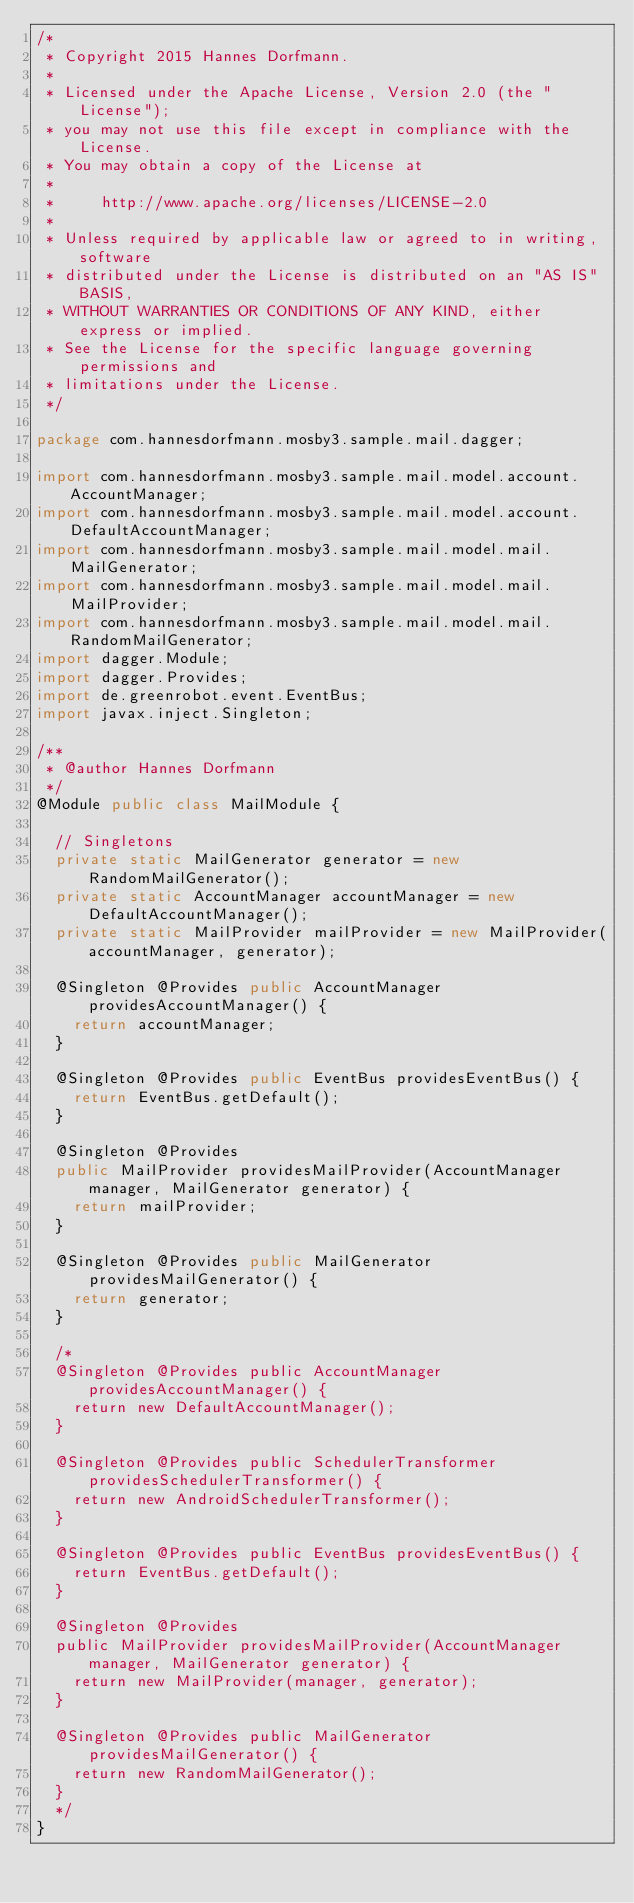Convert code to text. <code><loc_0><loc_0><loc_500><loc_500><_Java_>/*
 * Copyright 2015 Hannes Dorfmann.
 *
 * Licensed under the Apache License, Version 2.0 (the "License");
 * you may not use this file except in compliance with the License.
 * You may obtain a copy of the License at
 *
 *     http://www.apache.org/licenses/LICENSE-2.0
 *
 * Unless required by applicable law or agreed to in writing, software
 * distributed under the License is distributed on an "AS IS" BASIS,
 * WITHOUT WARRANTIES OR CONDITIONS OF ANY KIND, either express or implied.
 * See the License for the specific language governing permissions and
 * limitations under the License.
 */

package com.hannesdorfmann.mosby3.sample.mail.dagger;

import com.hannesdorfmann.mosby3.sample.mail.model.account.AccountManager;
import com.hannesdorfmann.mosby3.sample.mail.model.account.DefaultAccountManager;
import com.hannesdorfmann.mosby3.sample.mail.model.mail.MailGenerator;
import com.hannesdorfmann.mosby3.sample.mail.model.mail.MailProvider;
import com.hannesdorfmann.mosby3.sample.mail.model.mail.RandomMailGenerator;
import dagger.Module;
import dagger.Provides;
import de.greenrobot.event.EventBus;
import javax.inject.Singleton;

/**
 * @author Hannes Dorfmann
 */
@Module public class MailModule {

  // Singletons
  private static MailGenerator generator = new RandomMailGenerator();
  private static AccountManager accountManager = new DefaultAccountManager();
  private static MailProvider mailProvider = new MailProvider(accountManager, generator);

  @Singleton @Provides public AccountManager providesAccountManager() {
    return accountManager;
  }

  @Singleton @Provides public EventBus providesEventBus() {
    return EventBus.getDefault();
  }

  @Singleton @Provides
  public MailProvider providesMailProvider(AccountManager manager, MailGenerator generator) {
    return mailProvider;
  }

  @Singleton @Provides public MailGenerator providesMailGenerator() {
    return generator;
  }

  /*
  @Singleton @Provides public AccountManager providesAccountManager() {
    return new DefaultAccountManager();
  }

  @Singleton @Provides public SchedulerTransformer providesSchedulerTransformer() {
    return new AndroidSchedulerTransformer();
  }

  @Singleton @Provides public EventBus providesEventBus() {
    return EventBus.getDefault();
  }

  @Singleton @Provides
  public MailProvider providesMailProvider(AccountManager manager, MailGenerator generator) {
    return new MailProvider(manager, generator);
  }

  @Singleton @Provides public MailGenerator providesMailGenerator() {
    return new RandomMailGenerator();
  }
  */
}
</code> 